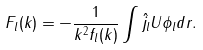Convert formula to latex. <formula><loc_0><loc_0><loc_500><loc_500>F _ { l } ( k ) = - \frac { 1 } { k ^ { 2 } f _ { l } ( k ) } \int \hat { j _ { l } } U \phi _ { l } d r .</formula> 